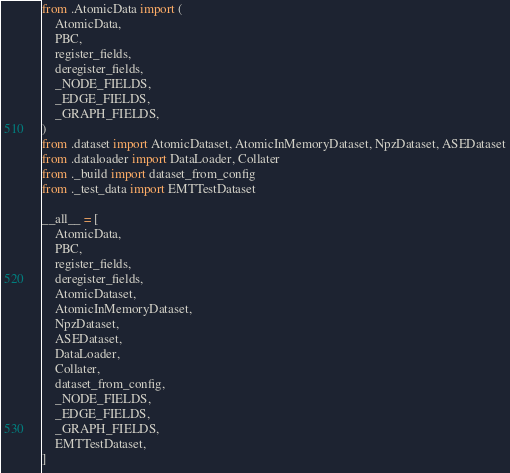<code> <loc_0><loc_0><loc_500><loc_500><_Python_>from .AtomicData import (
    AtomicData,
    PBC,
    register_fields,
    deregister_fields,
    _NODE_FIELDS,
    _EDGE_FIELDS,
    _GRAPH_FIELDS,
)
from .dataset import AtomicDataset, AtomicInMemoryDataset, NpzDataset, ASEDataset
from .dataloader import DataLoader, Collater
from ._build import dataset_from_config
from ._test_data import EMTTestDataset

__all__ = [
    AtomicData,
    PBC,
    register_fields,
    deregister_fields,
    AtomicDataset,
    AtomicInMemoryDataset,
    NpzDataset,
    ASEDataset,
    DataLoader,
    Collater,
    dataset_from_config,
    _NODE_FIELDS,
    _EDGE_FIELDS,
    _GRAPH_FIELDS,
    EMTTestDataset,
]
</code> 